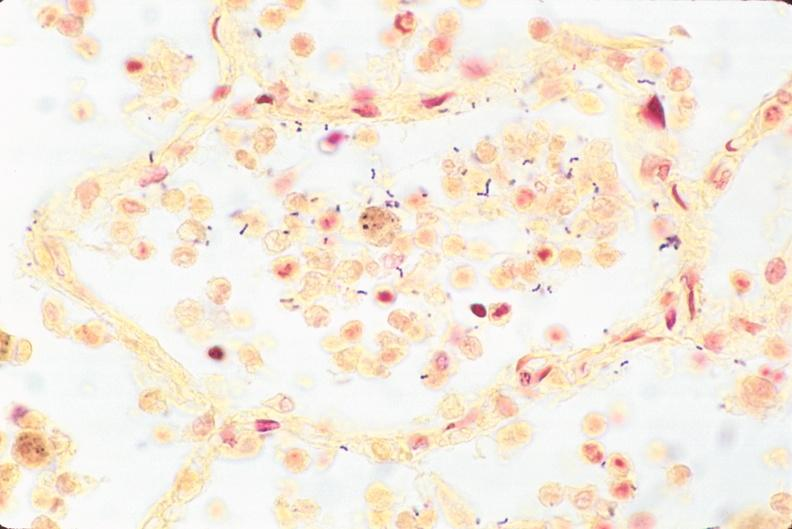where is this?
Answer the question using a single word or phrase. Lung 